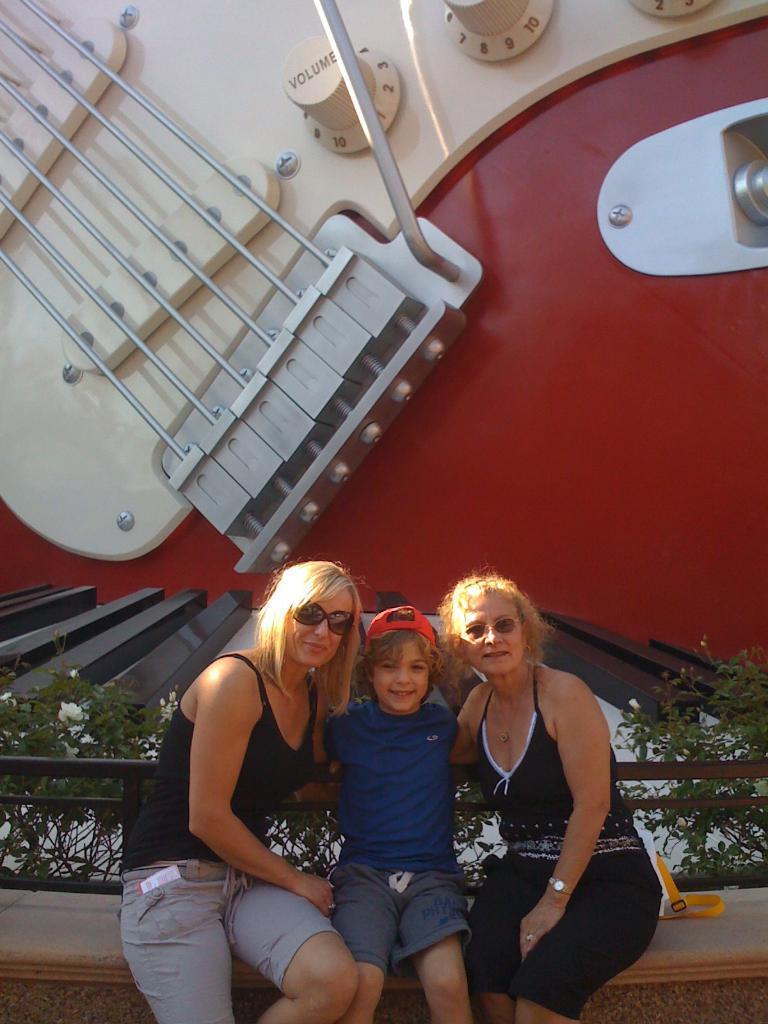Can you describe this image briefly? In this image, we can see some people sitting, in the background we can see a music instrument strings and some volume buttons. 